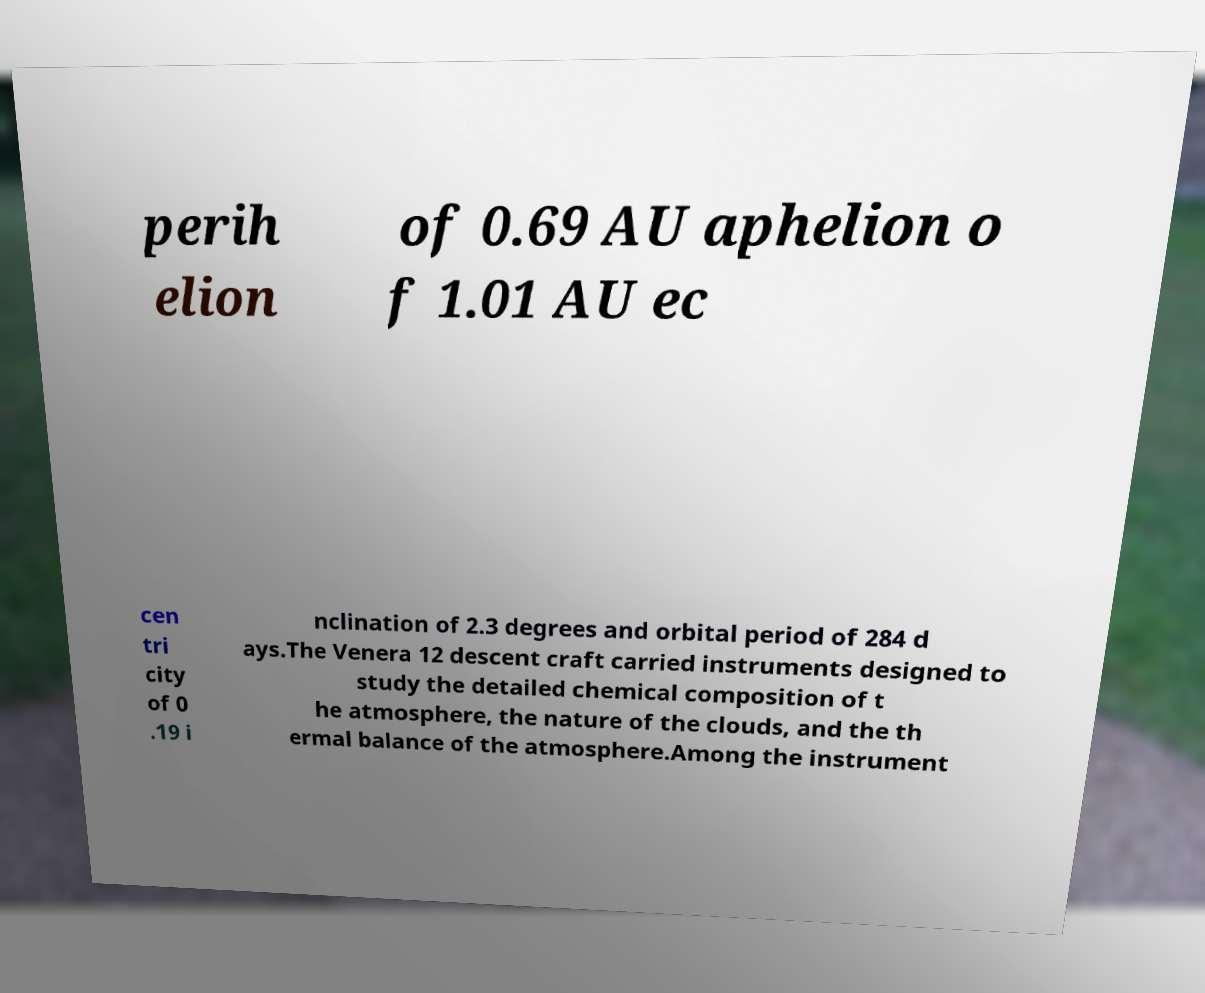Can you accurately transcribe the text from the provided image for me? perih elion of 0.69 AU aphelion o f 1.01 AU ec cen tri city of 0 .19 i nclination of 2.3 degrees and orbital period of 284 d ays.The Venera 12 descent craft carried instruments designed to study the detailed chemical composition of t he atmosphere, the nature of the clouds, and the th ermal balance of the atmosphere.Among the instrument 